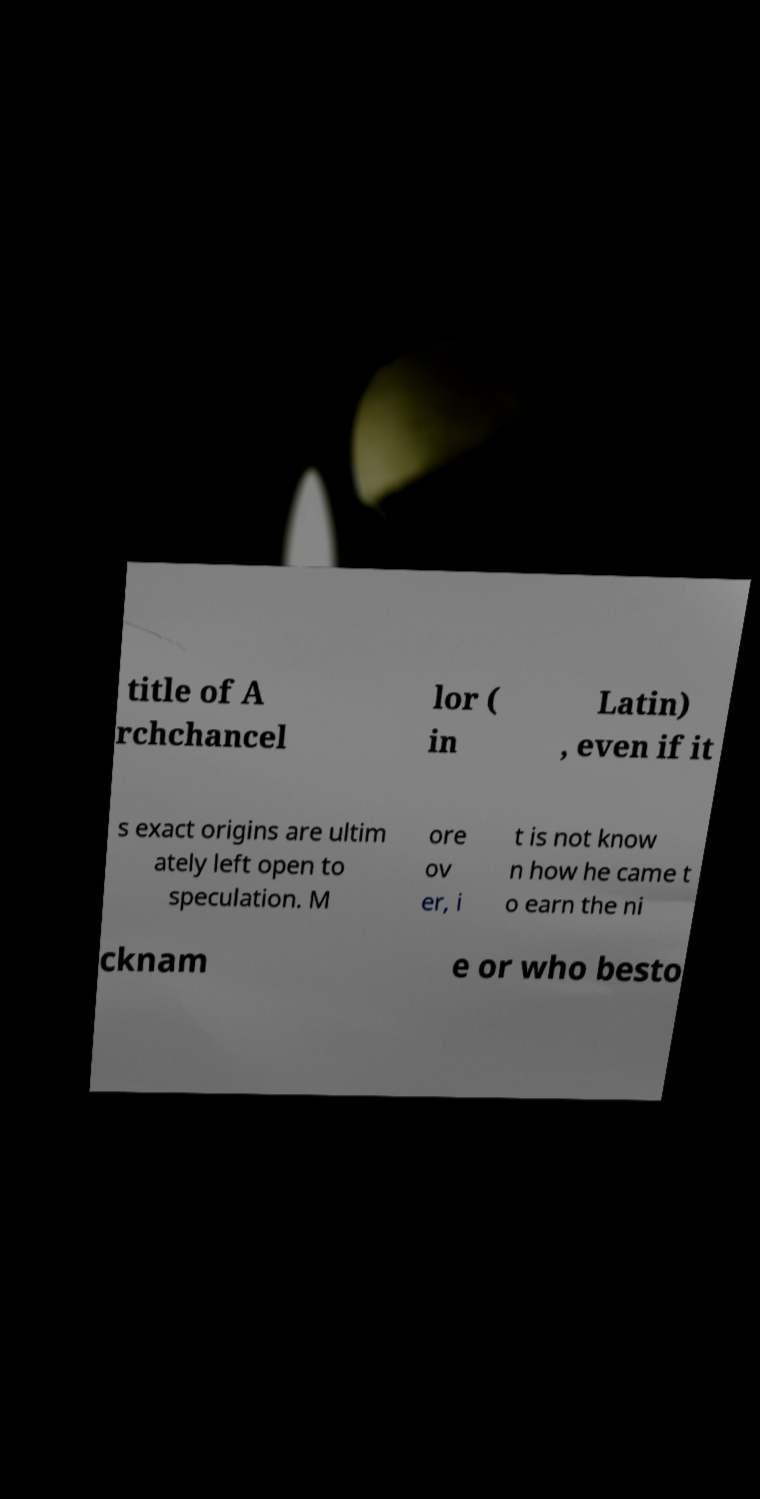Could you assist in decoding the text presented in this image and type it out clearly? title of A rchchancel lor ( in Latin) , even if it s exact origins are ultim ately left open to speculation. M ore ov er, i t is not know n how he came t o earn the ni cknam e or who besto 